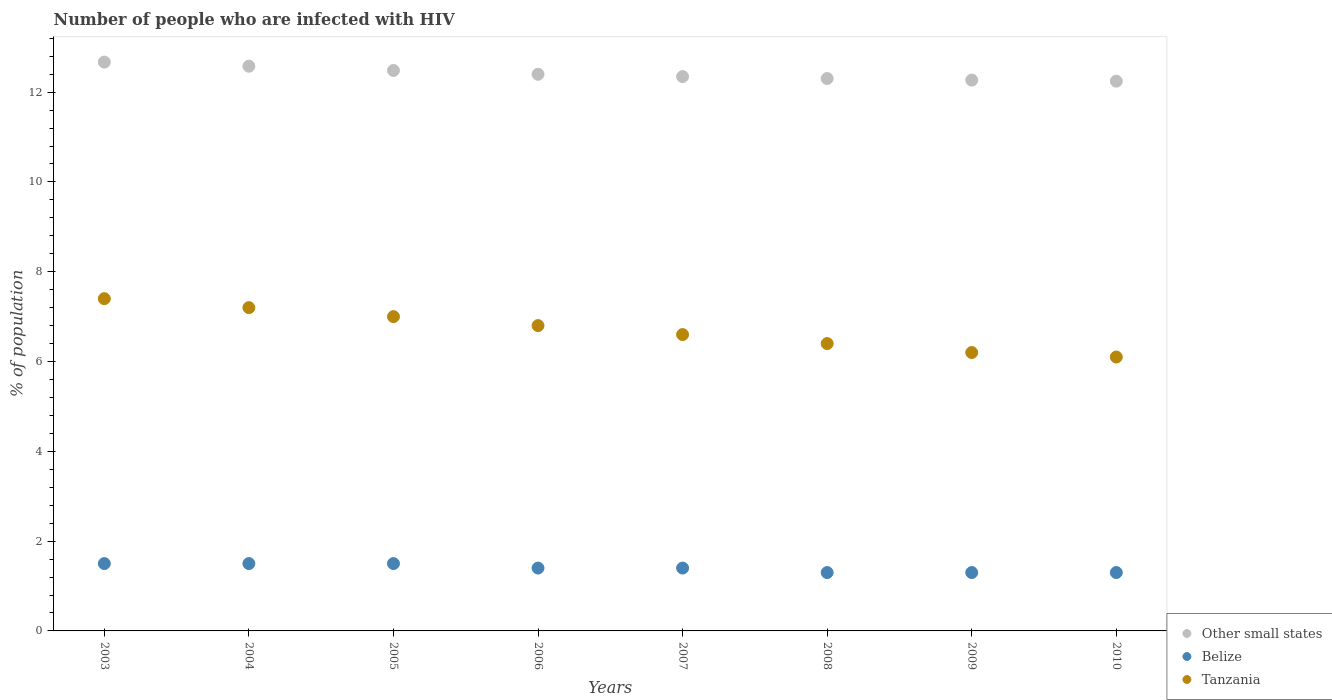Is the number of dotlines equal to the number of legend labels?
Keep it short and to the point. Yes. Across all years, what is the minimum percentage of HIV infected population in in Other small states?
Offer a terse response. 12.24. In which year was the percentage of HIV infected population in in Tanzania maximum?
Provide a short and direct response. 2003. In which year was the percentage of HIV infected population in in Belize minimum?
Ensure brevity in your answer.  2008. What is the total percentage of HIV infected population in in Other small states in the graph?
Your answer should be very brief. 99.29. What is the difference between the percentage of HIV infected population in in Belize in 2006 and that in 2010?
Offer a terse response. 0.1. What is the difference between the percentage of HIV infected population in in Belize in 2006 and the percentage of HIV infected population in in Tanzania in 2007?
Provide a succinct answer. -5.2. What is the average percentage of HIV infected population in in Belize per year?
Give a very brief answer. 1.4. In the year 2007, what is the difference between the percentage of HIV infected population in in Tanzania and percentage of HIV infected population in in Belize?
Provide a succinct answer. 5.2. In how many years, is the percentage of HIV infected population in in Belize greater than 11.2 %?
Your answer should be compact. 0. What is the ratio of the percentage of HIV infected population in in Belize in 2003 to that in 2009?
Ensure brevity in your answer.  1.15. Is the difference between the percentage of HIV infected population in in Tanzania in 2006 and 2008 greater than the difference between the percentage of HIV infected population in in Belize in 2006 and 2008?
Keep it short and to the point. Yes. What is the difference between the highest and the second highest percentage of HIV infected population in in Tanzania?
Ensure brevity in your answer.  0.2. What is the difference between the highest and the lowest percentage of HIV infected population in in Belize?
Provide a short and direct response. 0.2. In how many years, is the percentage of HIV infected population in in Other small states greater than the average percentage of HIV infected population in in Other small states taken over all years?
Offer a very short reply. 3. Is the sum of the percentage of HIV infected population in in Other small states in 2003 and 2006 greater than the maximum percentage of HIV infected population in in Belize across all years?
Your answer should be very brief. Yes. Is it the case that in every year, the sum of the percentage of HIV infected population in in Belize and percentage of HIV infected population in in Other small states  is greater than the percentage of HIV infected population in in Tanzania?
Keep it short and to the point. Yes. Is the percentage of HIV infected population in in Belize strictly less than the percentage of HIV infected population in in Other small states over the years?
Your response must be concise. Yes. Does the graph contain any zero values?
Your answer should be very brief. No. What is the title of the graph?
Your answer should be very brief. Number of people who are infected with HIV. What is the label or title of the X-axis?
Make the answer very short. Years. What is the label or title of the Y-axis?
Offer a very short reply. % of population. What is the % of population in Other small states in 2003?
Your answer should be very brief. 12.67. What is the % of population of Belize in 2003?
Offer a terse response. 1.5. What is the % of population in Other small states in 2004?
Provide a short and direct response. 12.58. What is the % of population of Tanzania in 2004?
Give a very brief answer. 7.2. What is the % of population in Other small states in 2005?
Offer a very short reply. 12.48. What is the % of population in Other small states in 2006?
Keep it short and to the point. 12.4. What is the % of population in Other small states in 2007?
Make the answer very short. 12.35. What is the % of population in Other small states in 2008?
Make the answer very short. 12.3. What is the % of population of Other small states in 2009?
Keep it short and to the point. 12.27. What is the % of population of Tanzania in 2009?
Offer a terse response. 6.2. What is the % of population in Other small states in 2010?
Provide a short and direct response. 12.24. What is the % of population in Belize in 2010?
Keep it short and to the point. 1.3. What is the % of population of Tanzania in 2010?
Give a very brief answer. 6.1. Across all years, what is the maximum % of population in Other small states?
Offer a very short reply. 12.67. Across all years, what is the maximum % of population in Belize?
Provide a short and direct response. 1.5. Across all years, what is the minimum % of population of Other small states?
Your answer should be compact. 12.24. What is the total % of population of Other small states in the graph?
Provide a short and direct response. 99.28. What is the total % of population in Belize in the graph?
Your answer should be compact. 11.2. What is the total % of population in Tanzania in the graph?
Make the answer very short. 53.7. What is the difference between the % of population of Other small states in 2003 and that in 2004?
Keep it short and to the point. 0.09. What is the difference between the % of population of Tanzania in 2003 and that in 2004?
Provide a short and direct response. 0.2. What is the difference between the % of population in Other small states in 2003 and that in 2005?
Provide a short and direct response. 0.19. What is the difference between the % of population of Other small states in 2003 and that in 2006?
Make the answer very short. 0.27. What is the difference between the % of population in Tanzania in 2003 and that in 2006?
Provide a succinct answer. 0.6. What is the difference between the % of population of Other small states in 2003 and that in 2007?
Give a very brief answer. 0.32. What is the difference between the % of population of Belize in 2003 and that in 2007?
Keep it short and to the point. 0.1. What is the difference between the % of population in Tanzania in 2003 and that in 2007?
Your answer should be compact. 0.8. What is the difference between the % of population of Other small states in 2003 and that in 2008?
Offer a very short reply. 0.37. What is the difference between the % of population of Other small states in 2003 and that in 2009?
Your answer should be compact. 0.4. What is the difference between the % of population in Belize in 2003 and that in 2009?
Provide a succinct answer. 0.2. What is the difference between the % of population of Tanzania in 2003 and that in 2009?
Your response must be concise. 1.2. What is the difference between the % of population of Other small states in 2003 and that in 2010?
Your answer should be very brief. 0.42. What is the difference between the % of population of Belize in 2003 and that in 2010?
Provide a short and direct response. 0.2. What is the difference between the % of population in Other small states in 2004 and that in 2005?
Your answer should be very brief. 0.09. What is the difference between the % of population of Belize in 2004 and that in 2005?
Offer a very short reply. 0. What is the difference between the % of population of Tanzania in 2004 and that in 2005?
Make the answer very short. 0.2. What is the difference between the % of population of Other small states in 2004 and that in 2006?
Keep it short and to the point. 0.18. What is the difference between the % of population of Other small states in 2004 and that in 2007?
Your answer should be compact. 0.23. What is the difference between the % of population in Belize in 2004 and that in 2007?
Provide a short and direct response. 0.1. What is the difference between the % of population in Other small states in 2004 and that in 2008?
Provide a short and direct response. 0.27. What is the difference between the % of population of Belize in 2004 and that in 2008?
Offer a terse response. 0.2. What is the difference between the % of population in Tanzania in 2004 and that in 2008?
Ensure brevity in your answer.  0.8. What is the difference between the % of population in Other small states in 2004 and that in 2009?
Ensure brevity in your answer.  0.31. What is the difference between the % of population in Belize in 2004 and that in 2009?
Provide a succinct answer. 0.2. What is the difference between the % of population of Tanzania in 2004 and that in 2009?
Ensure brevity in your answer.  1. What is the difference between the % of population in Other small states in 2004 and that in 2010?
Ensure brevity in your answer.  0.33. What is the difference between the % of population in Belize in 2004 and that in 2010?
Your answer should be compact. 0.2. What is the difference between the % of population of Other small states in 2005 and that in 2006?
Your answer should be very brief. 0.08. What is the difference between the % of population in Tanzania in 2005 and that in 2006?
Your response must be concise. 0.2. What is the difference between the % of population of Other small states in 2005 and that in 2007?
Provide a succinct answer. 0.14. What is the difference between the % of population of Other small states in 2005 and that in 2008?
Provide a succinct answer. 0.18. What is the difference between the % of population in Belize in 2005 and that in 2008?
Provide a succinct answer. 0.2. What is the difference between the % of population of Other small states in 2005 and that in 2009?
Provide a short and direct response. 0.21. What is the difference between the % of population in Belize in 2005 and that in 2009?
Give a very brief answer. 0.2. What is the difference between the % of population in Other small states in 2005 and that in 2010?
Your answer should be compact. 0.24. What is the difference between the % of population of Other small states in 2006 and that in 2007?
Give a very brief answer. 0.05. What is the difference between the % of population of Belize in 2006 and that in 2007?
Your response must be concise. 0. What is the difference between the % of population of Other small states in 2006 and that in 2008?
Provide a succinct answer. 0.09. What is the difference between the % of population of Tanzania in 2006 and that in 2008?
Your answer should be compact. 0.4. What is the difference between the % of population of Other small states in 2006 and that in 2009?
Provide a succinct answer. 0.13. What is the difference between the % of population in Belize in 2006 and that in 2009?
Keep it short and to the point. 0.1. What is the difference between the % of population in Other small states in 2006 and that in 2010?
Give a very brief answer. 0.15. What is the difference between the % of population of Belize in 2006 and that in 2010?
Keep it short and to the point. 0.1. What is the difference between the % of population of Other small states in 2007 and that in 2008?
Your answer should be compact. 0.04. What is the difference between the % of population of Tanzania in 2007 and that in 2008?
Your answer should be compact. 0.2. What is the difference between the % of population of Other small states in 2007 and that in 2009?
Offer a terse response. 0.08. What is the difference between the % of population in Tanzania in 2007 and that in 2009?
Your answer should be compact. 0.4. What is the difference between the % of population in Other small states in 2007 and that in 2010?
Make the answer very short. 0.1. What is the difference between the % of population of Belize in 2007 and that in 2010?
Make the answer very short. 0.1. What is the difference between the % of population in Other small states in 2008 and that in 2009?
Provide a succinct answer. 0.04. What is the difference between the % of population in Belize in 2008 and that in 2009?
Offer a very short reply. 0. What is the difference between the % of population of Other small states in 2008 and that in 2010?
Your response must be concise. 0.06. What is the difference between the % of population in Tanzania in 2008 and that in 2010?
Provide a succinct answer. 0.3. What is the difference between the % of population of Other small states in 2009 and that in 2010?
Offer a terse response. 0.02. What is the difference between the % of population of Belize in 2009 and that in 2010?
Your answer should be compact. 0. What is the difference between the % of population in Other small states in 2003 and the % of population in Belize in 2004?
Provide a succinct answer. 11.17. What is the difference between the % of population in Other small states in 2003 and the % of population in Tanzania in 2004?
Provide a short and direct response. 5.47. What is the difference between the % of population in Other small states in 2003 and the % of population in Belize in 2005?
Give a very brief answer. 11.17. What is the difference between the % of population in Other small states in 2003 and the % of population in Tanzania in 2005?
Keep it short and to the point. 5.67. What is the difference between the % of population in Belize in 2003 and the % of population in Tanzania in 2005?
Offer a terse response. -5.5. What is the difference between the % of population in Other small states in 2003 and the % of population in Belize in 2006?
Provide a short and direct response. 11.27. What is the difference between the % of population in Other small states in 2003 and the % of population in Tanzania in 2006?
Give a very brief answer. 5.87. What is the difference between the % of population of Belize in 2003 and the % of population of Tanzania in 2006?
Offer a terse response. -5.3. What is the difference between the % of population in Other small states in 2003 and the % of population in Belize in 2007?
Offer a very short reply. 11.27. What is the difference between the % of population of Other small states in 2003 and the % of population of Tanzania in 2007?
Your answer should be very brief. 6.07. What is the difference between the % of population of Other small states in 2003 and the % of population of Belize in 2008?
Your response must be concise. 11.37. What is the difference between the % of population in Other small states in 2003 and the % of population in Tanzania in 2008?
Provide a short and direct response. 6.27. What is the difference between the % of population in Belize in 2003 and the % of population in Tanzania in 2008?
Provide a short and direct response. -4.9. What is the difference between the % of population in Other small states in 2003 and the % of population in Belize in 2009?
Your answer should be very brief. 11.37. What is the difference between the % of population in Other small states in 2003 and the % of population in Tanzania in 2009?
Your answer should be very brief. 6.47. What is the difference between the % of population of Other small states in 2003 and the % of population of Belize in 2010?
Your answer should be very brief. 11.37. What is the difference between the % of population in Other small states in 2003 and the % of population in Tanzania in 2010?
Your answer should be very brief. 6.57. What is the difference between the % of population of Belize in 2003 and the % of population of Tanzania in 2010?
Provide a short and direct response. -4.6. What is the difference between the % of population of Other small states in 2004 and the % of population of Belize in 2005?
Provide a short and direct response. 11.08. What is the difference between the % of population in Other small states in 2004 and the % of population in Tanzania in 2005?
Provide a short and direct response. 5.58. What is the difference between the % of population in Other small states in 2004 and the % of population in Belize in 2006?
Offer a very short reply. 11.18. What is the difference between the % of population in Other small states in 2004 and the % of population in Tanzania in 2006?
Make the answer very short. 5.78. What is the difference between the % of population in Other small states in 2004 and the % of population in Belize in 2007?
Your answer should be compact. 11.18. What is the difference between the % of population of Other small states in 2004 and the % of population of Tanzania in 2007?
Your answer should be very brief. 5.98. What is the difference between the % of population of Other small states in 2004 and the % of population of Belize in 2008?
Provide a succinct answer. 11.28. What is the difference between the % of population of Other small states in 2004 and the % of population of Tanzania in 2008?
Offer a terse response. 6.18. What is the difference between the % of population of Belize in 2004 and the % of population of Tanzania in 2008?
Provide a short and direct response. -4.9. What is the difference between the % of population in Other small states in 2004 and the % of population in Belize in 2009?
Ensure brevity in your answer.  11.28. What is the difference between the % of population of Other small states in 2004 and the % of population of Tanzania in 2009?
Your answer should be very brief. 6.38. What is the difference between the % of population of Belize in 2004 and the % of population of Tanzania in 2009?
Your response must be concise. -4.7. What is the difference between the % of population of Other small states in 2004 and the % of population of Belize in 2010?
Keep it short and to the point. 11.28. What is the difference between the % of population of Other small states in 2004 and the % of population of Tanzania in 2010?
Offer a terse response. 6.48. What is the difference between the % of population of Other small states in 2005 and the % of population of Belize in 2006?
Provide a succinct answer. 11.08. What is the difference between the % of population in Other small states in 2005 and the % of population in Tanzania in 2006?
Give a very brief answer. 5.68. What is the difference between the % of population of Belize in 2005 and the % of population of Tanzania in 2006?
Offer a very short reply. -5.3. What is the difference between the % of population in Other small states in 2005 and the % of population in Belize in 2007?
Keep it short and to the point. 11.08. What is the difference between the % of population of Other small states in 2005 and the % of population of Tanzania in 2007?
Provide a short and direct response. 5.88. What is the difference between the % of population in Other small states in 2005 and the % of population in Belize in 2008?
Offer a very short reply. 11.18. What is the difference between the % of population in Other small states in 2005 and the % of population in Tanzania in 2008?
Offer a terse response. 6.08. What is the difference between the % of population of Belize in 2005 and the % of population of Tanzania in 2008?
Offer a terse response. -4.9. What is the difference between the % of population in Other small states in 2005 and the % of population in Belize in 2009?
Make the answer very short. 11.18. What is the difference between the % of population in Other small states in 2005 and the % of population in Tanzania in 2009?
Ensure brevity in your answer.  6.28. What is the difference between the % of population of Other small states in 2005 and the % of population of Belize in 2010?
Provide a short and direct response. 11.18. What is the difference between the % of population of Other small states in 2005 and the % of population of Tanzania in 2010?
Give a very brief answer. 6.38. What is the difference between the % of population in Other small states in 2006 and the % of population in Belize in 2007?
Provide a succinct answer. 11. What is the difference between the % of population in Other small states in 2006 and the % of population in Tanzania in 2007?
Provide a succinct answer. 5.8. What is the difference between the % of population in Belize in 2006 and the % of population in Tanzania in 2007?
Keep it short and to the point. -5.2. What is the difference between the % of population of Other small states in 2006 and the % of population of Belize in 2008?
Your answer should be compact. 11.1. What is the difference between the % of population in Other small states in 2006 and the % of population in Tanzania in 2008?
Keep it short and to the point. 6. What is the difference between the % of population in Belize in 2006 and the % of population in Tanzania in 2008?
Your answer should be very brief. -5. What is the difference between the % of population of Other small states in 2006 and the % of population of Belize in 2009?
Your answer should be very brief. 11.1. What is the difference between the % of population of Other small states in 2006 and the % of population of Tanzania in 2009?
Ensure brevity in your answer.  6.2. What is the difference between the % of population in Other small states in 2006 and the % of population in Belize in 2010?
Your answer should be compact. 11.1. What is the difference between the % of population of Other small states in 2006 and the % of population of Tanzania in 2010?
Ensure brevity in your answer.  6.3. What is the difference between the % of population of Belize in 2006 and the % of population of Tanzania in 2010?
Offer a terse response. -4.7. What is the difference between the % of population in Other small states in 2007 and the % of population in Belize in 2008?
Offer a very short reply. 11.05. What is the difference between the % of population in Other small states in 2007 and the % of population in Tanzania in 2008?
Make the answer very short. 5.95. What is the difference between the % of population of Other small states in 2007 and the % of population of Belize in 2009?
Your answer should be very brief. 11.05. What is the difference between the % of population in Other small states in 2007 and the % of population in Tanzania in 2009?
Your response must be concise. 6.15. What is the difference between the % of population of Other small states in 2007 and the % of population of Belize in 2010?
Provide a succinct answer. 11.05. What is the difference between the % of population of Other small states in 2007 and the % of population of Tanzania in 2010?
Provide a short and direct response. 6.25. What is the difference between the % of population of Other small states in 2008 and the % of population of Belize in 2009?
Provide a short and direct response. 11. What is the difference between the % of population in Other small states in 2008 and the % of population in Tanzania in 2009?
Ensure brevity in your answer.  6.1. What is the difference between the % of population of Belize in 2008 and the % of population of Tanzania in 2009?
Offer a terse response. -4.9. What is the difference between the % of population of Other small states in 2008 and the % of population of Belize in 2010?
Ensure brevity in your answer.  11. What is the difference between the % of population of Other small states in 2008 and the % of population of Tanzania in 2010?
Ensure brevity in your answer.  6.2. What is the difference between the % of population of Belize in 2008 and the % of population of Tanzania in 2010?
Ensure brevity in your answer.  -4.8. What is the difference between the % of population in Other small states in 2009 and the % of population in Belize in 2010?
Keep it short and to the point. 10.97. What is the difference between the % of population of Other small states in 2009 and the % of population of Tanzania in 2010?
Offer a terse response. 6.17. What is the difference between the % of population in Belize in 2009 and the % of population in Tanzania in 2010?
Provide a succinct answer. -4.8. What is the average % of population of Other small states per year?
Provide a succinct answer. 12.41. What is the average % of population in Belize per year?
Keep it short and to the point. 1.4. What is the average % of population in Tanzania per year?
Keep it short and to the point. 6.71. In the year 2003, what is the difference between the % of population of Other small states and % of population of Belize?
Give a very brief answer. 11.17. In the year 2003, what is the difference between the % of population in Other small states and % of population in Tanzania?
Ensure brevity in your answer.  5.27. In the year 2004, what is the difference between the % of population of Other small states and % of population of Belize?
Your response must be concise. 11.08. In the year 2004, what is the difference between the % of population of Other small states and % of population of Tanzania?
Make the answer very short. 5.38. In the year 2004, what is the difference between the % of population in Belize and % of population in Tanzania?
Your response must be concise. -5.7. In the year 2005, what is the difference between the % of population in Other small states and % of population in Belize?
Your response must be concise. 10.98. In the year 2005, what is the difference between the % of population in Other small states and % of population in Tanzania?
Offer a very short reply. 5.48. In the year 2006, what is the difference between the % of population in Other small states and % of population in Belize?
Your answer should be compact. 11. In the year 2006, what is the difference between the % of population of Other small states and % of population of Tanzania?
Ensure brevity in your answer.  5.6. In the year 2007, what is the difference between the % of population of Other small states and % of population of Belize?
Give a very brief answer. 10.95. In the year 2007, what is the difference between the % of population in Other small states and % of population in Tanzania?
Your response must be concise. 5.75. In the year 2007, what is the difference between the % of population of Belize and % of population of Tanzania?
Provide a short and direct response. -5.2. In the year 2008, what is the difference between the % of population of Other small states and % of population of Belize?
Offer a terse response. 11. In the year 2008, what is the difference between the % of population of Other small states and % of population of Tanzania?
Provide a short and direct response. 5.9. In the year 2008, what is the difference between the % of population in Belize and % of population in Tanzania?
Offer a very short reply. -5.1. In the year 2009, what is the difference between the % of population of Other small states and % of population of Belize?
Offer a terse response. 10.97. In the year 2009, what is the difference between the % of population in Other small states and % of population in Tanzania?
Offer a terse response. 6.07. In the year 2010, what is the difference between the % of population of Other small states and % of population of Belize?
Keep it short and to the point. 10.94. In the year 2010, what is the difference between the % of population of Other small states and % of population of Tanzania?
Provide a succinct answer. 6.14. In the year 2010, what is the difference between the % of population of Belize and % of population of Tanzania?
Your answer should be very brief. -4.8. What is the ratio of the % of population in Other small states in 2003 to that in 2004?
Give a very brief answer. 1.01. What is the ratio of the % of population of Tanzania in 2003 to that in 2004?
Give a very brief answer. 1.03. What is the ratio of the % of population in Other small states in 2003 to that in 2005?
Give a very brief answer. 1.01. What is the ratio of the % of population in Tanzania in 2003 to that in 2005?
Offer a terse response. 1.06. What is the ratio of the % of population in Other small states in 2003 to that in 2006?
Provide a short and direct response. 1.02. What is the ratio of the % of population in Belize in 2003 to that in 2006?
Give a very brief answer. 1.07. What is the ratio of the % of population of Tanzania in 2003 to that in 2006?
Keep it short and to the point. 1.09. What is the ratio of the % of population of Other small states in 2003 to that in 2007?
Offer a very short reply. 1.03. What is the ratio of the % of population in Belize in 2003 to that in 2007?
Provide a succinct answer. 1.07. What is the ratio of the % of population of Tanzania in 2003 to that in 2007?
Provide a short and direct response. 1.12. What is the ratio of the % of population in Other small states in 2003 to that in 2008?
Your response must be concise. 1.03. What is the ratio of the % of population of Belize in 2003 to that in 2008?
Your answer should be compact. 1.15. What is the ratio of the % of population of Tanzania in 2003 to that in 2008?
Make the answer very short. 1.16. What is the ratio of the % of population in Other small states in 2003 to that in 2009?
Keep it short and to the point. 1.03. What is the ratio of the % of population in Belize in 2003 to that in 2009?
Provide a succinct answer. 1.15. What is the ratio of the % of population of Tanzania in 2003 to that in 2009?
Provide a succinct answer. 1.19. What is the ratio of the % of population in Other small states in 2003 to that in 2010?
Your response must be concise. 1.03. What is the ratio of the % of population of Belize in 2003 to that in 2010?
Your answer should be compact. 1.15. What is the ratio of the % of population in Tanzania in 2003 to that in 2010?
Offer a terse response. 1.21. What is the ratio of the % of population in Other small states in 2004 to that in 2005?
Ensure brevity in your answer.  1.01. What is the ratio of the % of population in Belize in 2004 to that in 2005?
Your answer should be compact. 1. What is the ratio of the % of population in Tanzania in 2004 to that in 2005?
Offer a very short reply. 1.03. What is the ratio of the % of population in Other small states in 2004 to that in 2006?
Provide a short and direct response. 1.01. What is the ratio of the % of population of Belize in 2004 to that in 2006?
Your answer should be very brief. 1.07. What is the ratio of the % of population of Tanzania in 2004 to that in 2006?
Your response must be concise. 1.06. What is the ratio of the % of population in Other small states in 2004 to that in 2007?
Make the answer very short. 1.02. What is the ratio of the % of population in Belize in 2004 to that in 2007?
Your answer should be compact. 1.07. What is the ratio of the % of population of Tanzania in 2004 to that in 2007?
Your answer should be compact. 1.09. What is the ratio of the % of population of Other small states in 2004 to that in 2008?
Your answer should be compact. 1.02. What is the ratio of the % of population in Belize in 2004 to that in 2008?
Ensure brevity in your answer.  1.15. What is the ratio of the % of population in Tanzania in 2004 to that in 2008?
Offer a very short reply. 1.12. What is the ratio of the % of population in Other small states in 2004 to that in 2009?
Make the answer very short. 1.03. What is the ratio of the % of population in Belize in 2004 to that in 2009?
Make the answer very short. 1.15. What is the ratio of the % of population in Tanzania in 2004 to that in 2009?
Make the answer very short. 1.16. What is the ratio of the % of population in Other small states in 2004 to that in 2010?
Ensure brevity in your answer.  1.03. What is the ratio of the % of population in Belize in 2004 to that in 2010?
Ensure brevity in your answer.  1.15. What is the ratio of the % of population of Tanzania in 2004 to that in 2010?
Your response must be concise. 1.18. What is the ratio of the % of population in Other small states in 2005 to that in 2006?
Give a very brief answer. 1.01. What is the ratio of the % of population in Belize in 2005 to that in 2006?
Your answer should be compact. 1.07. What is the ratio of the % of population of Tanzania in 2005 to that in 2006?
Offer a terse response. 1.03. What is the ratio of the % of population of Other small states in 2005 to that in 2007?
Keep it short and to the point. 1.01. What is the ratio of the % of population in Belize in 2005 to that in 2007?
Ensure brevity in your answer.  1.07. What is the ratio of the % of population of Tanzania in 2005 to that in 2007?
Your response must be concise. 1.06. What is the ratio of the % of population in Other small states in 2005 to that in 2008?
Your answer should be very brief. 1.01. What is the ratio of the % of population of Belize in 2005 to that in 2008?
Ensure brevity in your answer.  1.15. What is the ratio of the % of population in Tanzania in 2005 to that in 2008?
Your response must be concise. 1.09. What is the ratio of the % of population in Other small states in 2005 to that in 2009?
Provide a short and direct response. 1.02. What is the ratio of the % of population in Belize in 2005 to that in 2009?
Give a very brief answer. 1.15. What is the ratio of the % of population in Tanzania in 2005 to that in 2009?
Your answer should be compact. 1.13. What is the ratio of the % of population of Other small states in 2005 to that in 2010?
Ensure brevity in your answer.  1.02. What is the ratio of the % of population of Belize in 2005 to that in 2010?
Provide a short and direct response. 1.15. What is the ratio of the % of population of Tanzania in 2005 to that in 2010?
Provide a succinct answer. 1.15. What is the ratio of the % of population of Belize in 2006 to that in 2007?
Ensure brevity in your answer.  1. What is the ratio of the % of population of Tanzania in 2006 to that in 2007?
Ensure brevity in your answer.  1.03. What is the ratio of the % of population of Other small states in 2006 to that in 2008?
Your answer should be very brief. 1.01. What is the ratio of the % of population in Belize in 2006 to that in 2008?
Your answer should be very brief. 1.08. What is the ratio of the % of population of Tanzania in 2006 to that in 2008?
Ensure brevity in your answer.  1.06. What is the ratio of the % of population in Other small states in 2006 to that in 2009?
Your response must be concise. 1.01. What is the ratio of the % of population of Tanzania in 2006 to that in 2009?
Offer a very short reply. 1.1. What is the ratio of the % of population in Other small states in 2006 to that in 2010?
Offer a very short reply. 1.01. What is the ratio of the % of population of Belize in 2006 to that in 2010?
Give a very brief answer. 1.08. What is the ratio of the % of population of Tanzania in 2006 to that in 2010?
Your answer should be compact. 1.11. What is the ratio of the % of population in Other small states in 2007 to that in 2008?
Your response must be concise. 1. What is the ratio of the % of population in Tanzania in 2007 to that in 2008?
Provide a succinct answer. 1.03. What is the ratio of the % of population in Belize in 2007 to that in 2009?
Your response must be concise. 1.08. What is the ratio of the % of population of Tanzania in 2007 to that in 2009?
Make the answer very short. 1.06. What is the ratio of the % of population in Other small states in 2007 to that in 2010?
Keep it short and to the point. 1.01. What is the ratio of the % of population in Belize in 2007 to that in 2010?
Keep it short and to the point. 1.08. What is the ratio of the % of population in Tanzania in 2007 to that in 2010?
Offer a very short reply. 1.08. What is the ratio of the % of population in Other small states in 2008 to that in 2009?
Make the answer very short. 1. What is the ratio of the % of population in Belize in 2008 to that in 2009?
Ensure brevity in your answer.  1. What is the ratio of the % of population of Tanzania in 2008 to that in 2009?
Provide a short and direct response. 1.03. What is the ratio of the % of population in Belize in 2008 to that in 2010?
Make the answer very short. 1. What is the ratio of the % of population in Tanzania in 2008 to that in 2010?
Ensure brevity in your answer.  1.05. What is the ratio of the % of population in Belize in 2009 to that in 2010?
Keep it short and to the point. 1. What is the ratio of the % of population of Tanzania in 2009 to that in 2010?
Give a very brief answer. 1.02. What is the difference between the highest and the second highest % of population of Other small states?
Your answer should be very brief. 0.09. What is the difference between the highest and the second highest % of population of Belize?
Make the answer very short. 0. What is the difference between the highest and the lowest % of population of Other small states?
Your answer should be compact. 0.42. 